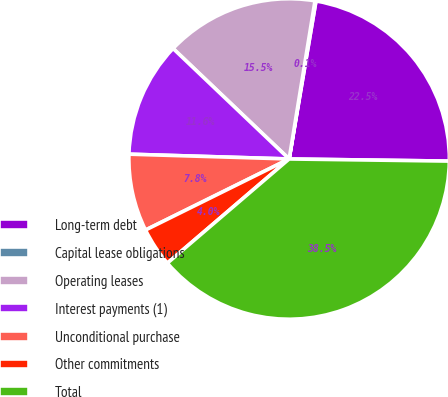Convert chart. <chart><loc_0><loc_0><loc_500><loc_500><pie_chart><fcel>Long-term debt<fcel>Capital lease obligations<fcel>Operating leases<fcel>Interest payments (1)<fcel>Unconditional purchase<fcel>Other commitments<fcel>Total<nl><fcel>22.53%<fcel>0.1%<fcel>15.47%<fcel>11.63%<fcel>7.79%<fcel>3.95%<fcel>38.52%<nl></chart> 